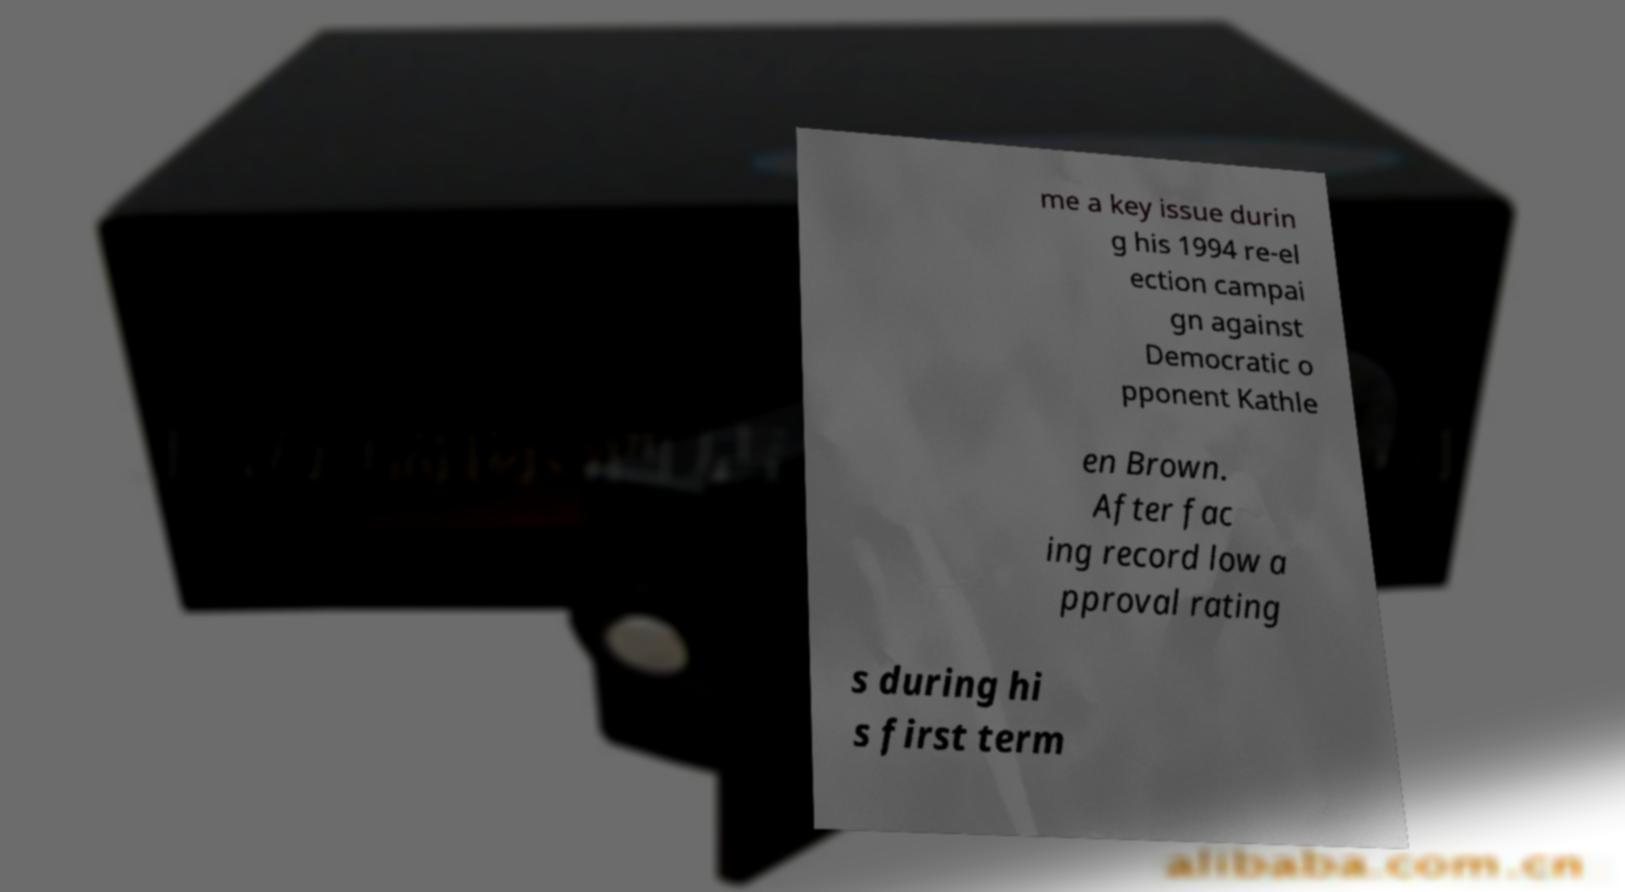Can you accurately transcribe the text from the provided image for me? me a key issue durin g his 1994 re-el ection campai gn against Democratic o pponent Kathle en Brown. After fac ing record low a pproval rating s during hi s first term 